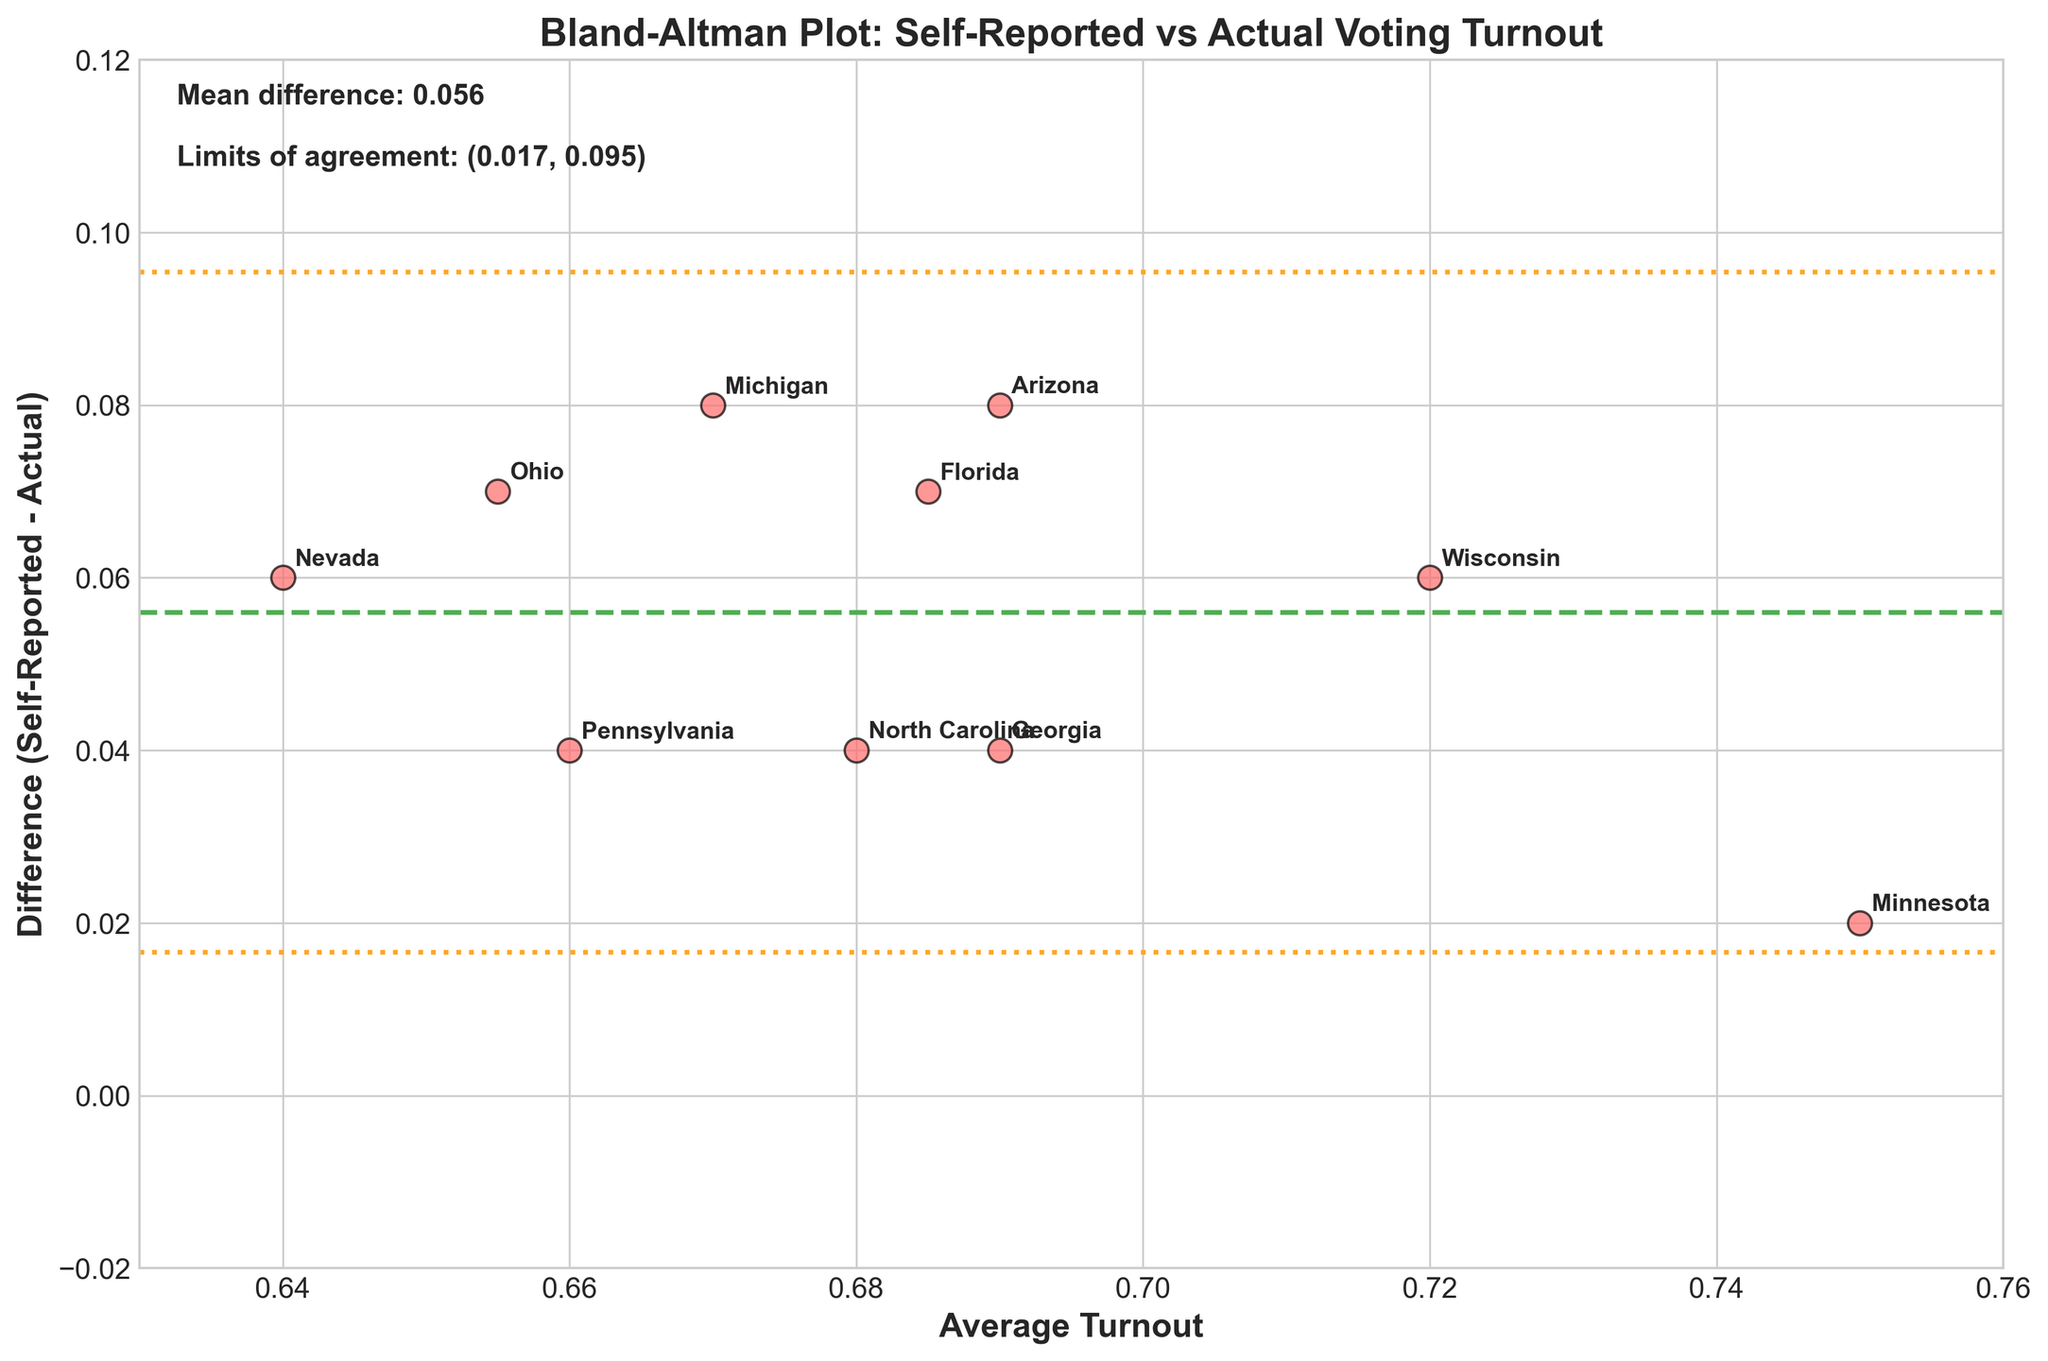How many states are represented in the plot? Count the number of unique state labels shown on the plot. Each point is labeled with a different state name. There are labels for Florida, Pennsylvania, Michigan, Wisconsin, Ohio, North Carolina, Arizona, Georgia, Minnesota, and Nevada.
Answer: 10 What is the overall mean difference in turnout between self-reported and actual voting? This is directly displayed on the plot as "Mean difference: X.XXX" where X.XXX represents the mean difference value calculated between self-reported and actual turnout.
Answer: 0.045 Which state has the largest positive discrepancy between self-reported and actual turnout? Identify the point with the highest positive Y-value, which represents the difference (Self-Reported - Actual). The state label at this point will indicate the state with the largest positive discrepancy.
Answer: Florida What are the limits of agreement? The limits of agreement are displayed on the plot as "Limits of agreement: (X.XXX, Y.YYY)" where X.XXX and Y.YYY represent the lower and upper limits respectively. These lines are marked on the plot with dotted lines.
Answer: (0.010, 0.080) Which state has the smallest average turnout? Identify the point with the lowest X-value, which represents the average turnout. The state label at this point will indicate the state with the smallest average turnout.
Answer: Nevada Do any states fall outside the limits of agreement? Compare the difference values (Y-values) for each state against the limits of agreement range (0.010, 0.080). If any state's Y-value is outside this range, that state falls outside the limits.
Answer: No What is the difference between self-reported and actual turnout in Minnesota? Locate the point associated with Minnesota and note its Y-value, which represents the difference (Self-Reported - Actual).
Answer: 0.02 How many states have self-reported turnouts higher than the actual turnout by more than 5%? Identify points with Y-values greater than 0.05. Count these points to determine the number of states fitting the criteria.
Answer: 5 Which state has the highest average turnout? Identify the point with the highest X-value, which represents the average turnout. The state label at this point will indicate the state with the highest average turnout.
Answer: Minnesota Compare the self-reported versus actual turnout discrepancies between Wisconsin and Ohio. Locate the points for Wisconsin and Ohio. Wisconsin's difference value is its Y-value (Self-Reported - Actual). Ohio's difference value is its Y-value. Compare these two values to see which is greater.
Answer: Wisconsin is greater 